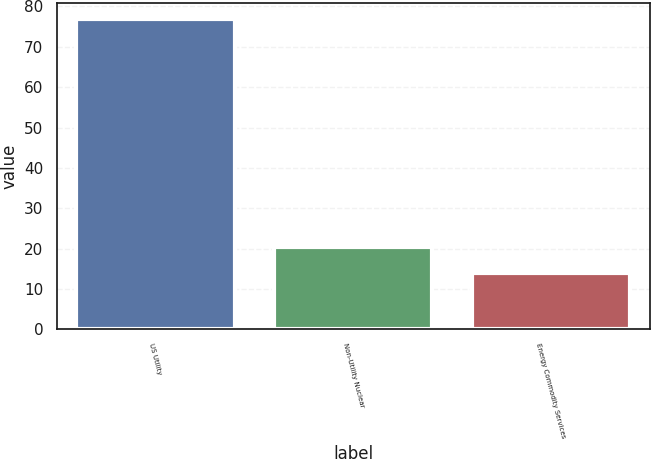Convert chart. <chart><loc_0><loc_0><loc_500><loc_500><bar_chart><fcel>US Utility<fcel>Non-Utility Nuclear<fcel>Energy Commodity Services<nl><fcel>77<fcel>20.3<fcel>14<nl></chart> 